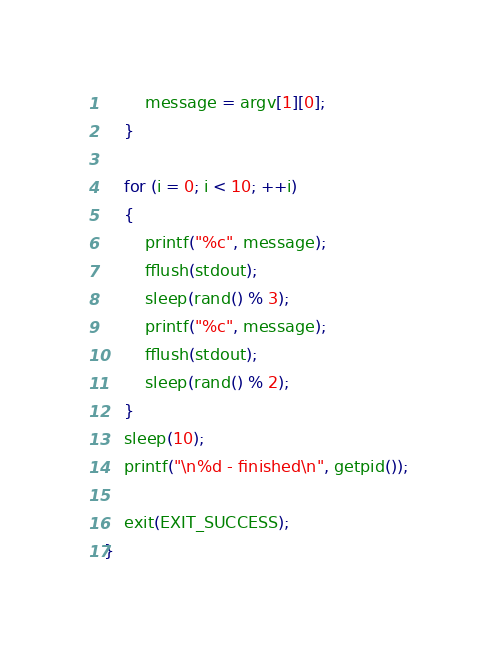<code> <loc_0><loc_0><loc_500><loc_500><_C_>        message = argv[1][0];
    }

    for (i = 0; i < 10; ++i)
    {
        printf("%c", message);
        fflush(stdout);
        sleep(rand() % 3);
        printf("%c", message);
        fflush(stdout);
        sleep(rand() % 2);
    }
    sleep(10);
    printf("\n%d - finished\n", getpid());

    exit(EXIT_SUCCESS);
}</code> 